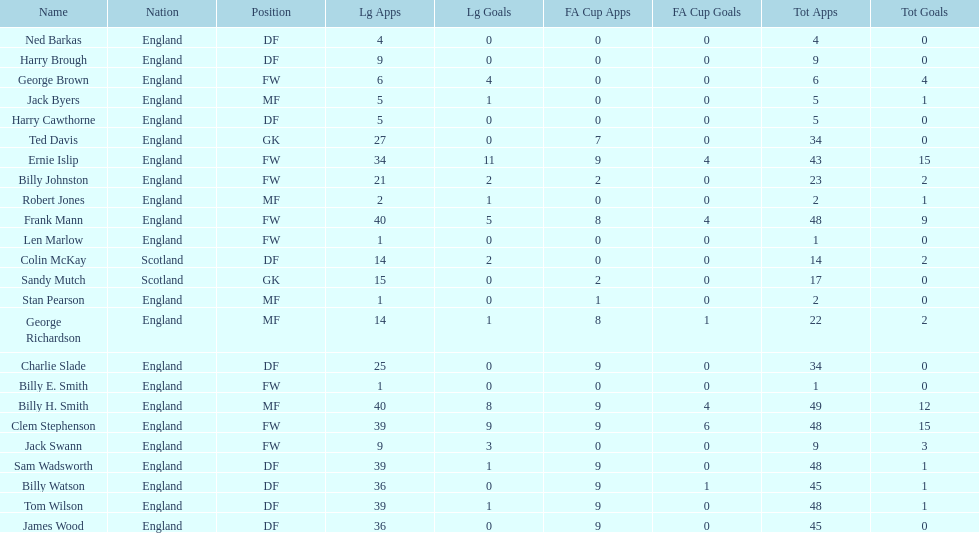Average number of goals scored by players from scotland 1. 